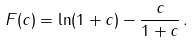<formula> <loc_0><loc_0><loc_500><loc_500>F ( c ) = \ln ( 1 + c ) - \frac { c } { 1 + c } \, .</formula> 